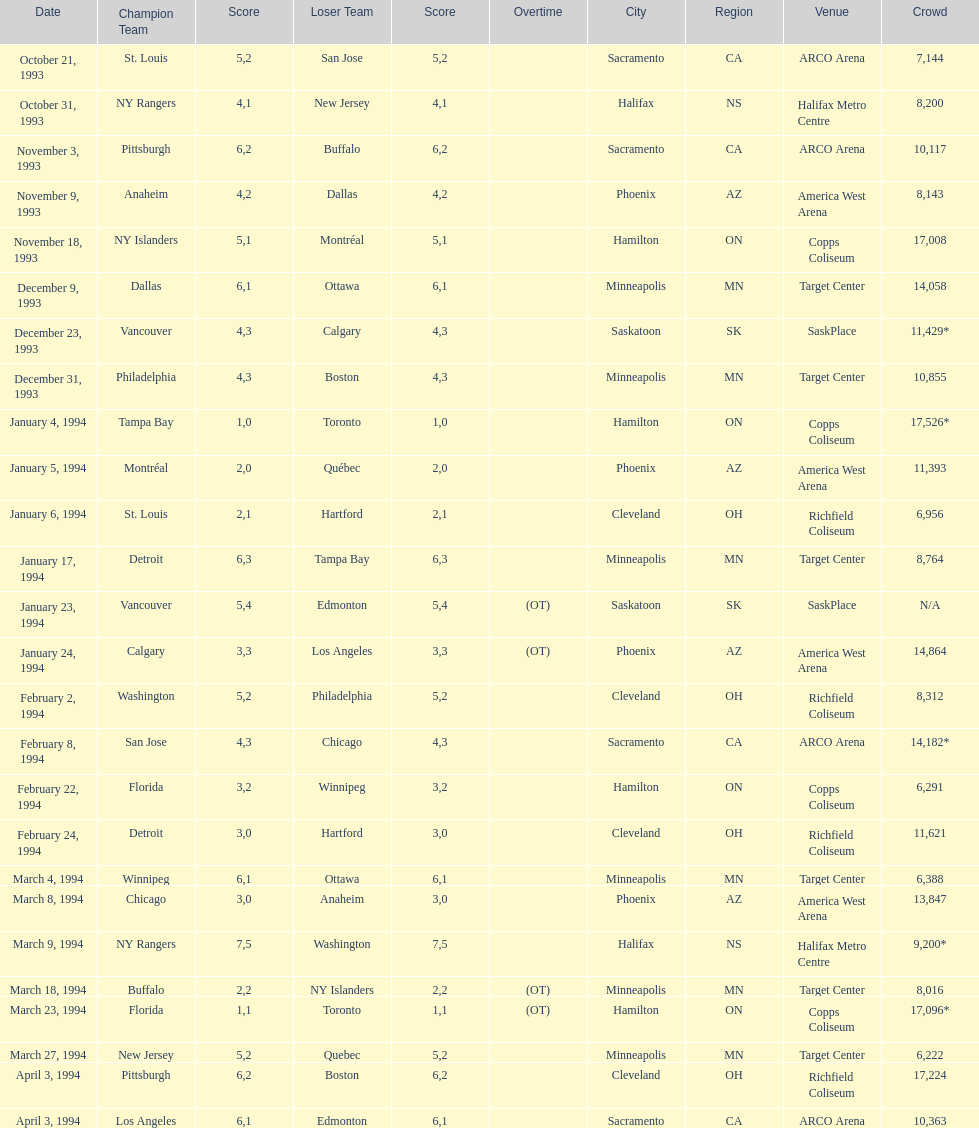How many more people attended the november 18, 1993 games than the november 9th game? 8865. 